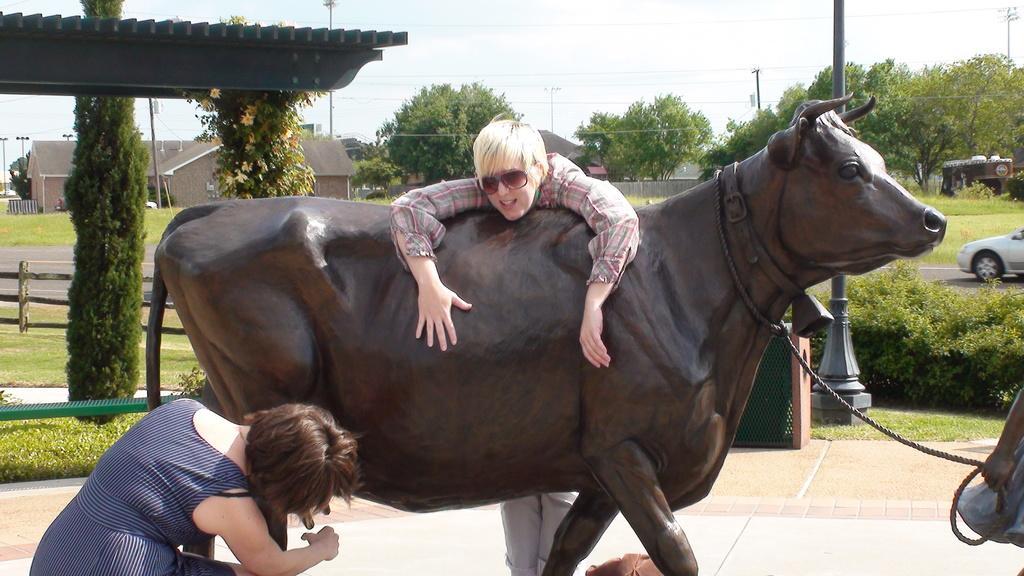How would you summarize this image in a sentence or two? In the middle of the image we can see an animal statue and two persons standing beside it. In the background we can see chain, motor vehicle, electric pole, electric cables, buildings, wooden grill, creepers, trees and ground. 